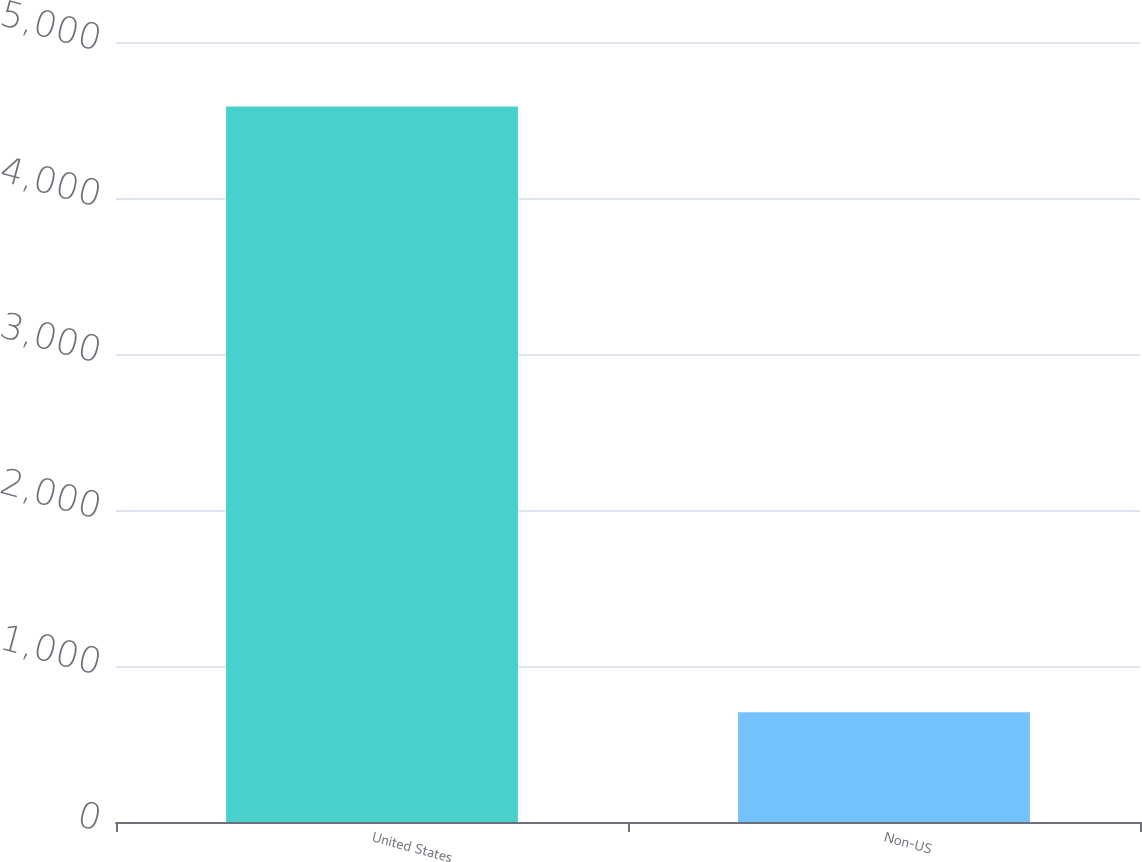Convert chart. <chart><loc_0><loc_0><loc_500><loc_500><bar_chart><fcel>United States<fcel>Non-US<nl><fcel>4586<fcel>704<nl></chart> 